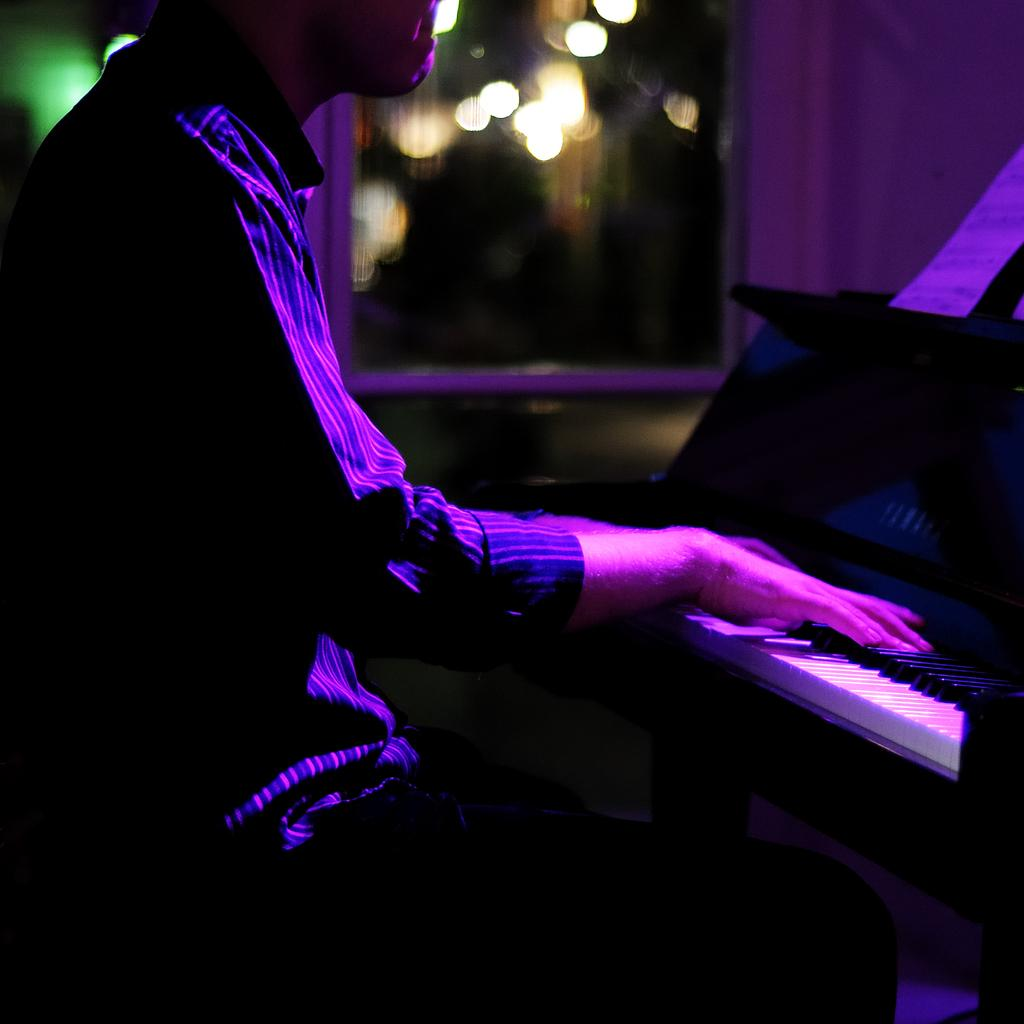What is the man in the image doing? The man is playing a piano in the image. What is the man's position in the image? The man is sitting on a chair in the image. What is placed on top of the piano? There is a paper on top of the piano in the image. What can be seen in the background of the image? There are lights in the background of the image. What type of soup is the man eating while playing the piano in the image? There is no soup present in the image; the man is playing the piano and there is a paper on top of it. 